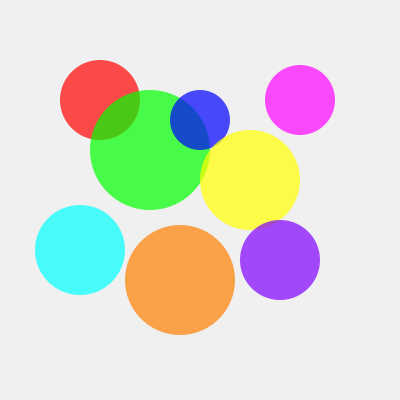Recall our project on crowd estimation techniques. If this diagram represents a bird's-eye view of a crowded scene where each circle represents a group of people, estimate the total number of groups visible. Consider that partially overlapping circles should be counted as separate groups. To estimate the number of groups in this crowded scene, we need to carefully count each distinct circle, even when they overlap. Let's approach this step-by-step:

1. First, let's identify the clearly visible, non-overlapping circles:
   - Red circle in the top-left
   - Purple circle in the top-right
   - Cyan circle in the bottom-left
   - Orange circle in the bottom-center
   - Purple circle in the bottom-right

   Count so far: 5 groups

2. Now, let's look at the overlapping circles in the center:
   - Green circle (largest, centered)
   - Blue circle (small, overlapping with green and yellow)
   - Yellow circle (overlapping with green and blue)

   These add 3 more groups, bringing our count to 8.

3. Double-check: Ensure we haven't missed any circles due to overlaps.

By carefully examining the image and counting each distinct circle, regardless of overlap, we can determine that there are 8 separate groups represented in this crowded scene.
Answer: 8 groups 